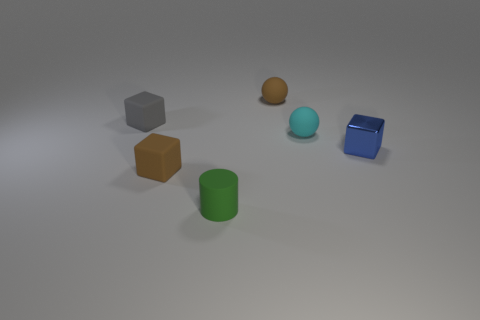Add 3 blocks. How many objects exist? 9 Subtract all balls. How many objects are left? 4 Add 4 small matte objects. How many small matte objects exist? 9 Subtract 0 brown cylinders. How many objects are left? 6 Subtract all shiny blocks. Subtract all small brown rubber objects. How many objects are left? 3 Add 5 tiny rubber objects. How many tiny rubber objects are left? 10 